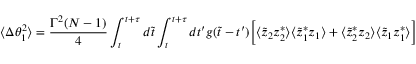<formula> <loc_0><loc_0><loc_500><loc_500>\langle \Delta \theta _ { 1 } ^ { 2 } \rangle = { \frac { \Gamma ^ { 2 } ( N - 1 ) } { 4 } } \int _ { t } ^ { t + \tau } d \tilde { t } \int _ { t } ^ { t + \tau } d t ^ { \prime } g ( \tilde { t } - t ^ { \prime } ) \left [ \langle \tilde { z } _ { 2 } z _ { 2 } ^ { * } \rangle \langle \tilde { z } _ { 1 } ^ { * } z _ { 1 } \rangle + \langle \tilde { z } _ { 2 } ^ { * } z _ { 2 } \rangle \langle \tilde { z } _ { 1 } z _ { 1 } ^ { * } \rangle \right ]</formula> 